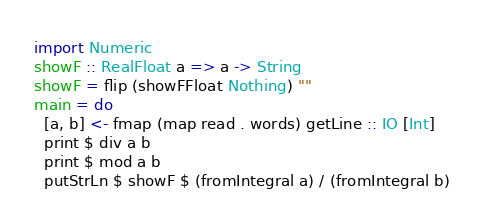<code> <loc_0><loc_0><loc_500><loc_500><_Haskell_>import Numeric
showF :: RealFloat a => a -> String
showF = flip (showFFloat Nothing) ""
main = do
  [a, b] <- fmap (map read . words) getLine :: IO [Int]
  print $ div a b
  print $ mod a b
  putStrLn $ showF $ (fromIntegral a) / (fromIntegral b)</code> 